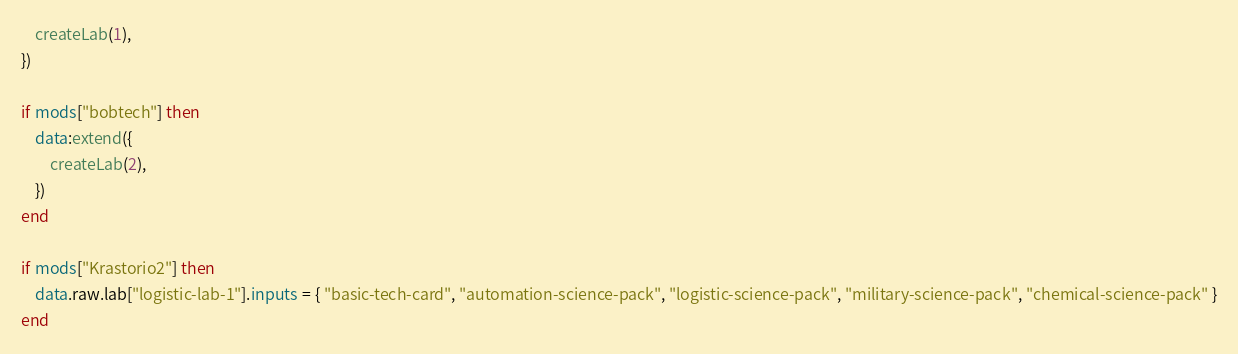<code> <loc_0><loc_0><loc_500><loc_500><_Lua_>    createLab(1),
})

if mods["bobtech"] then
    data:extend({
        createLab(2),
    })
end

if mods["Krastorio2"] then
    data.raw.lab["logistic-lab-1"].inputs = { "basic-tech-card", "automation-science-pack", "logistic-science-pack", "military-science-pack", "chemical-science-pack" }
end
</code> 